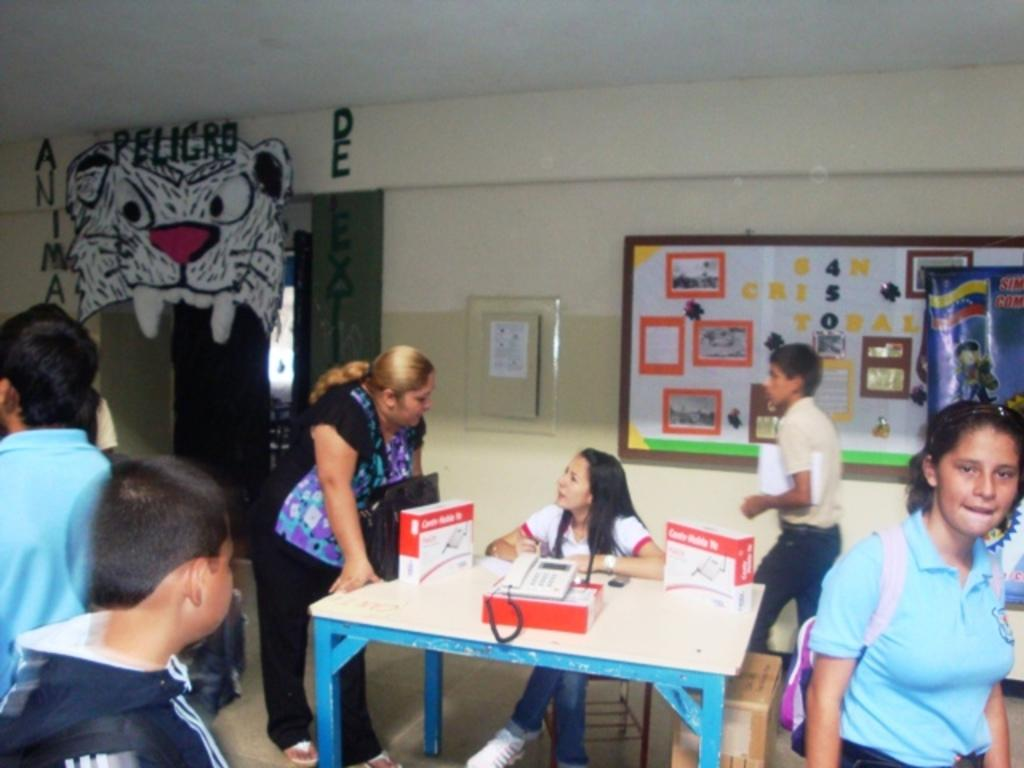How many people are in the image? There is a group of persons in the image. What are the people in the image doing? Some of the persons are sitting, while others are standing. What can be seen on the wall in the background of the image? There are paintings on the wall in the background of the image. What object is on the table in the image? There is a telephone on a table in the image. What type of jam is being spread on the earth in the image? There is no jam or earth present in the image; it features a group of persons, paintings on the wall, and a telephone on a table. 